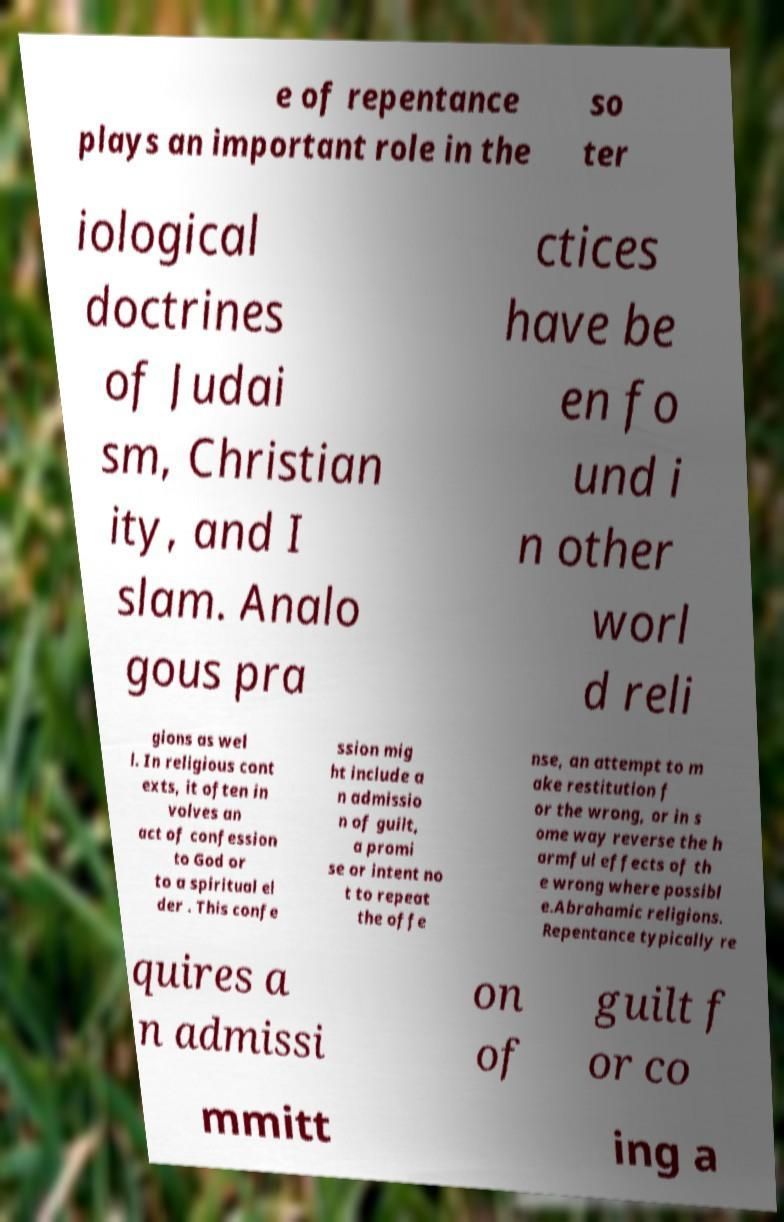For documentation purposes, I need the text within this image transcribed. Could you provide that? e of repentance plays an important role in the so ter iological doctrines of Judai sm, Christian ity, and I slam. Analo gous pra ctices have be en fo und i n other worl d reli gions as wel l. In religious cont exts, it often in volves an act of confession to God or to a spiritual el der . This confe ssion mig ht include a n admissio n of guilt, a promi se or intent no t to repeat the offe nse, an attempt to m ake restitution f or the wrong, or in s ome way reverse the h armful effects of th e wrong where possibl e.Abrahamic religions. Repentance typically re quires a n admissi on of guilt f or co mmitt ing a 